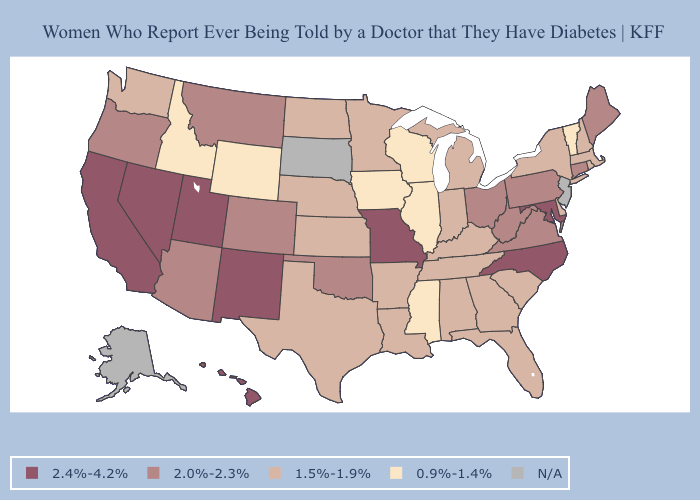Does the first symbol in the legend represent the smallest category?
Concise answer only. No. What is the lowest value in states that border Wyoming?
Answer briefly. 0.9%-1.4%. Name the states that have a value in the range 2.0%-2.3%?
Be succinct. Arizona, Colorado, Connecticut, Maine, Montana, Ohio, Oklahoma, Oregon, Pennsylvania, Virginia, West Virginia. Does Wisconsin have the lowest value in the MidWest?
Give a very brief answer. Yes. What is the lowest value in the USA?
Be succinct. 0.9%-1.4%. What is the lowest value in states that border Oregon?
Short answer required. 0.9%-1.4%. What is the highest value in the South ?
Answer briefly. 2.4%-4.2%. Name the states that have a value in the range 2.4%-4.2%?
Write a very short answer. California, Hawaii, Maryland, Missouri, Nevada, New Mexico, North Carolina, Utah. Name the states that have a value in the range N/A?
Keep it brief. Alaska, New Jersey, South Dakota. What is the value of Indiana?
Write a very short answer. 1.5%-1.9%. What is the highest value in states that border Minnesota?
Give a very brief answer. 1.5%-1.9%. Which states have the lowest value in the USA?
Short answer required. Idaho, Illinois, Iowa, Mississippi, Vermont, Wisconsin, Wyoming. Does the first symbol in the legend represent the smallest category?
Keep it brief. No. Which states hav the highest value in the South?
Write a very short answer. Maryland, North Carolina. Does the first symbol in the legend represent the smallest category?
Quick response, please. No. 